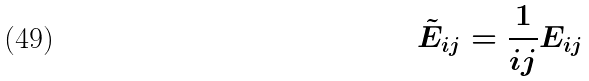Convert formula to latex. <formula><loc_0><loc_0><loc_500><loc_500>\tilde { E } _ { i j } = \frac { 1 } { i j } E _ { i j }</formula> 